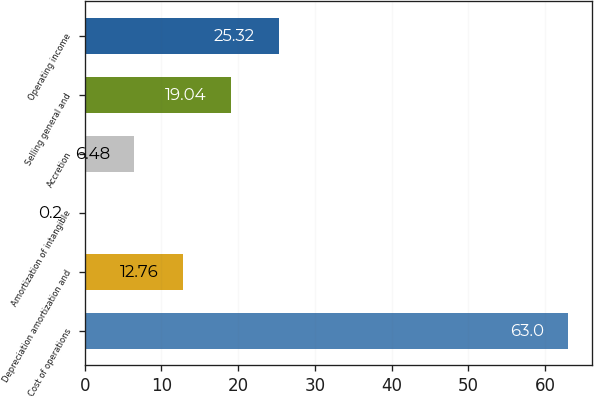Convert chart to OTSL. <chart><loc_0><loc_0><loc_500><loc_500><bar_chart><fcel>Cost of operations<fcel>Depreciation amortization and<fcel>Amortization of intangible<fcel>Accretion<fcel>Selling general and<fcel>Operating income<nl><fcel>63<fcel>12.76<fcel>0.2<fcel>6.48<fcel>19.04<fcel>25.32<nl></chart> 